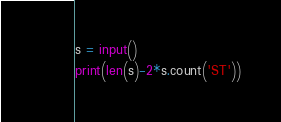Convert code to text. <code><loc_0><loc_0><loc_500><loc_500><_Python_>s = input()
print(len(s)-2*s.count('ST'))</code> 